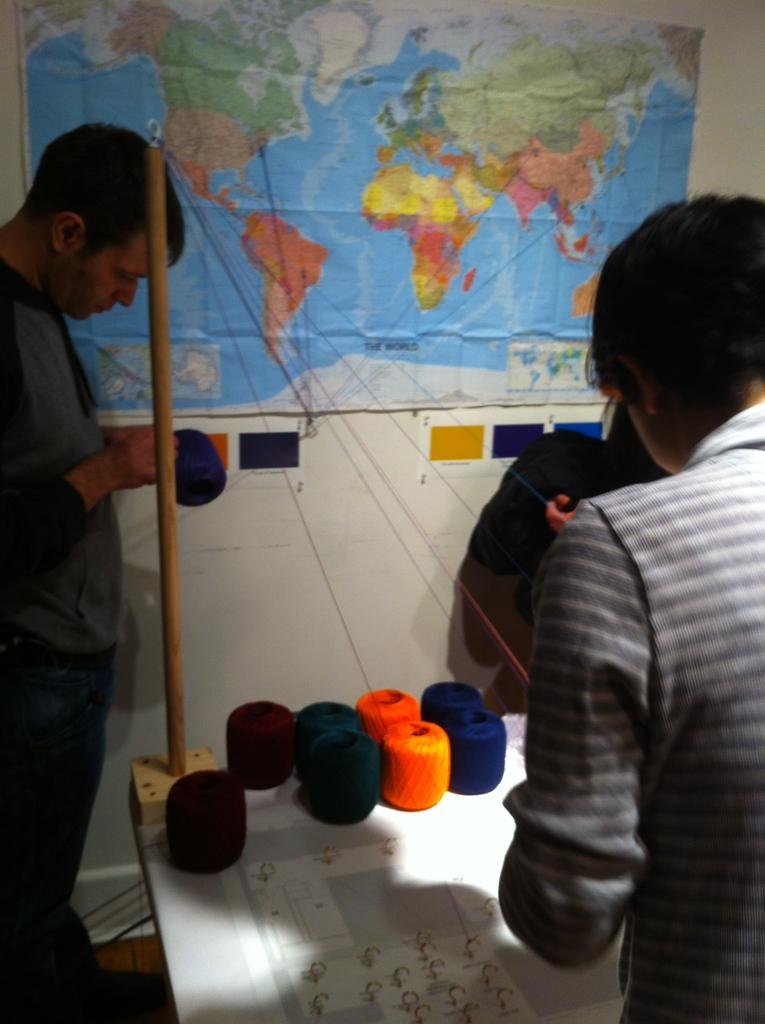What objects are on the table in the image? There are thread rolls on the table. How many people are in the picture? There are two members in the picture. What can be seen on the wall in the background? There is a world map on the wall in the background. What type of door can be seen in the image? There is no door visible in the image. What journey are the two members in the picture embarking on? The image does not provide any information about a journey or the intentions of the two members. 